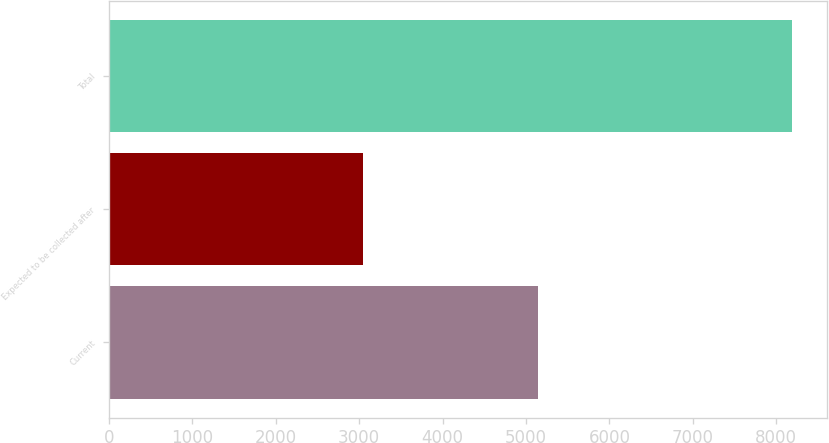<chart> <loc_0><loc_0><loc_500><loc_500><bar_chart><fcel>Current<fcel>Expected to be collected after<fcel>Total<nl><fcel>5149<fcel>3045<fcel>8194<nl></chart> 